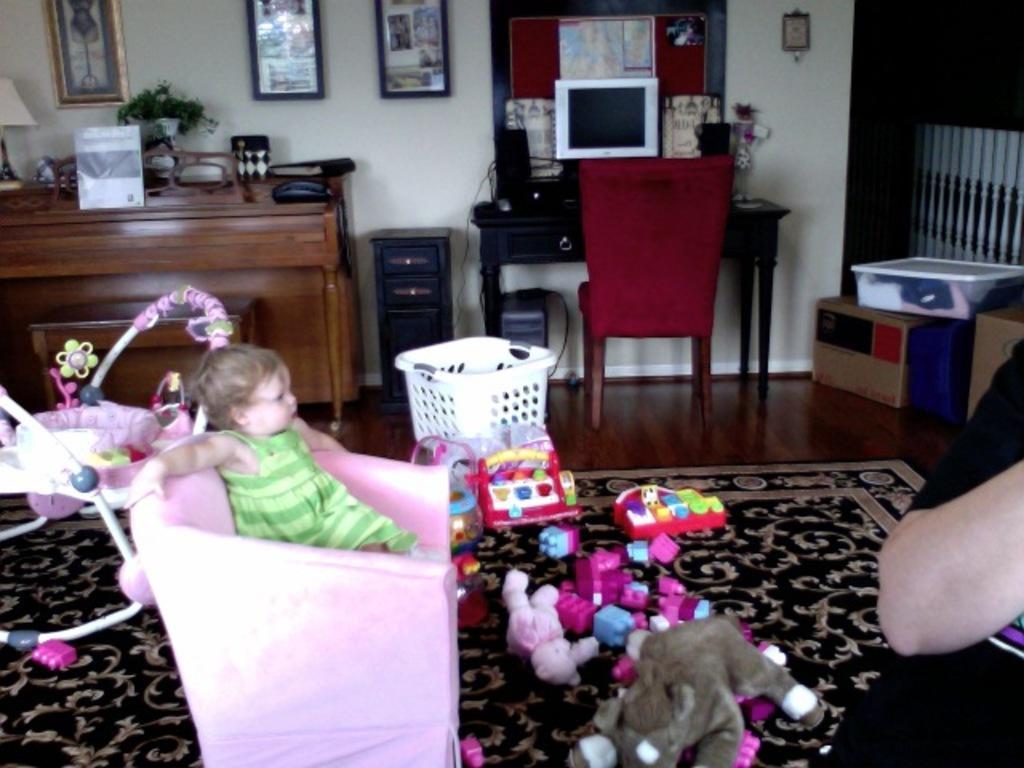Could you give a brief overview of what you see in this image? In the image we can see there is a baby who is sitting on a pink colour chair and on the floor there are lot of toys and on the table there is a monitor and on the wall there are photo frames kept and on the floor there is a doormat. 